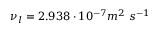<formula> <loc_0><loc_0><loc_500><loc_500>\nu _ { l } = 2 . 9 3 8 \cdot 1 0 ^ { - 7 } m ^ { 2 } \ s ^ { - 1 }</formula> 